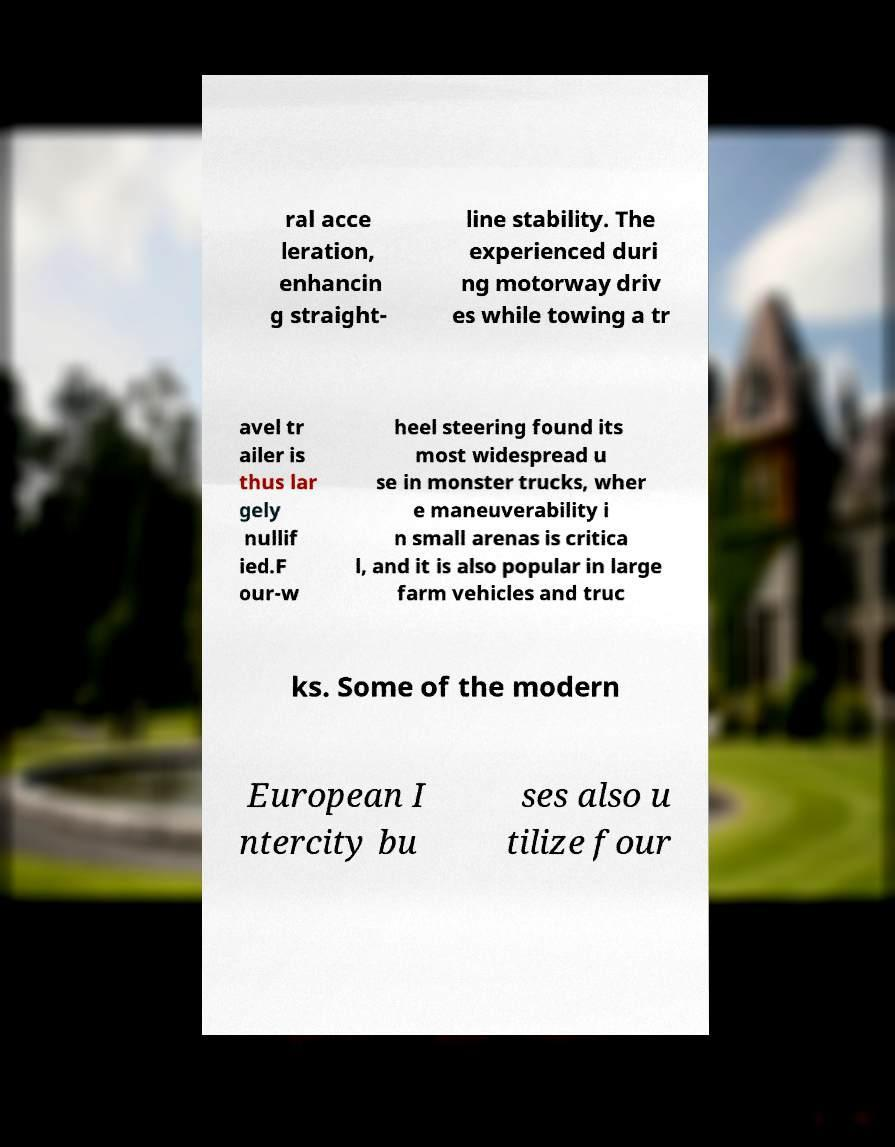Can you read and provide the text displayed in the image?This photo seems to have some interesting text. Can you extract and type it out for me? ral acce leration, enhancin g straight- line stability. The experienced duri ng motorway driv es while towing a tr avel tr ailer is thus lar gely nullif ied.F our-w heel steering found its most widespread u se in monster trucks, wher e maneuverability i n small arenas is critica l, and it is also popular in large farm vehicles and truc ks. Some of the modern European I ntercity bu ses also u tilize four 